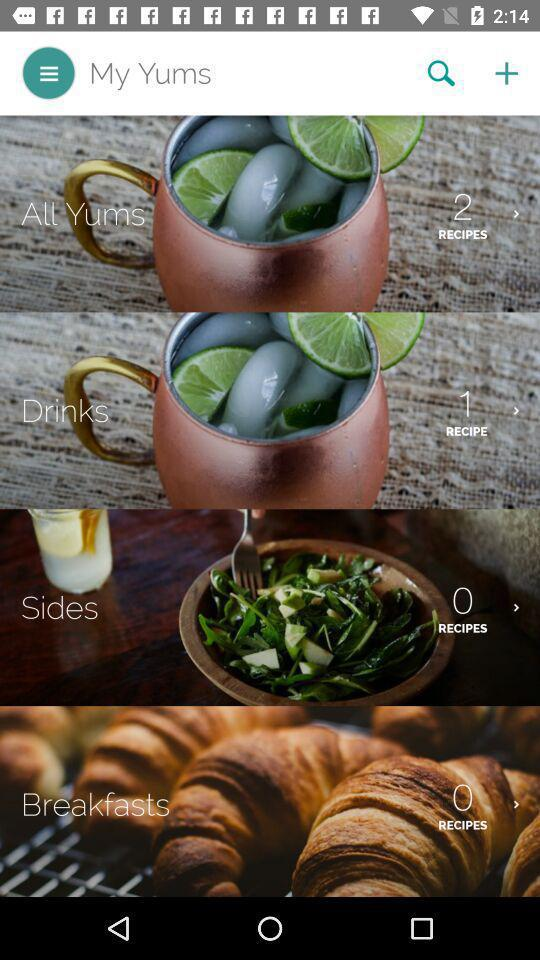How many recipes are there in "All Yums"? There are 2 recipes in "All Yums". 